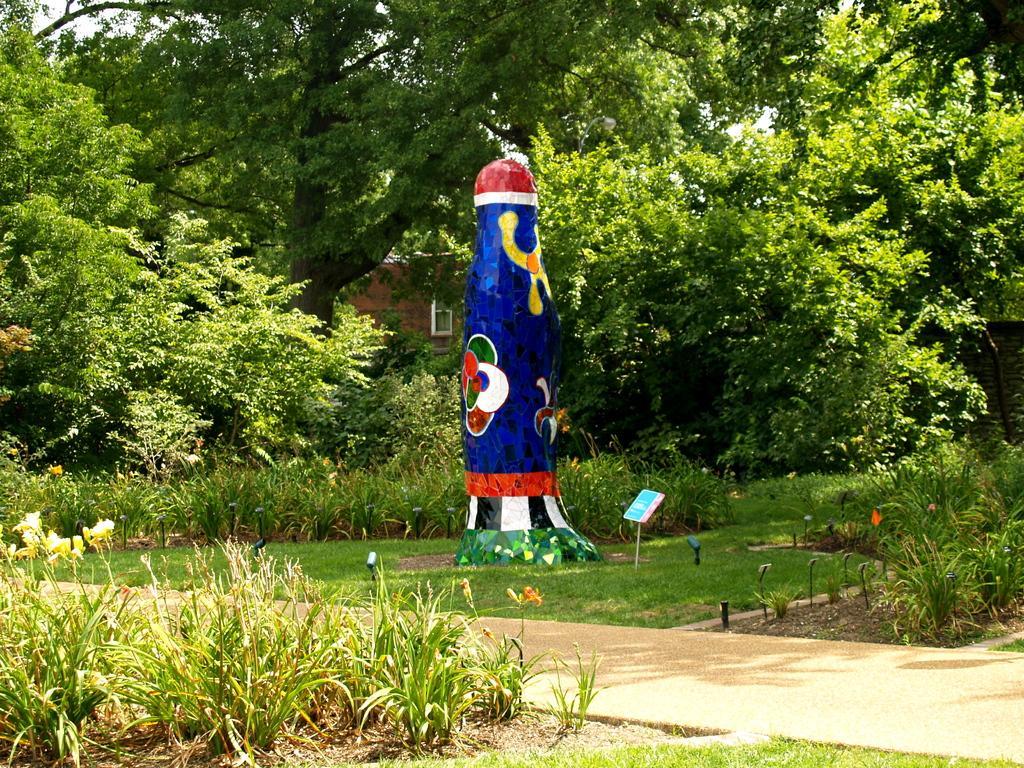What type of area is depicted in the image? There is a garden in the image. What is the surface of the garden made of? The garden has a grass surface. What types of vegetation can be found in the garden? There are plants and trees in the garden. Can you describe the bottle-like structure on the grass surface? There is a bottle-like structure on the grass surface, but its purpose or function is not clear from the image. What can be seen in the background of the image? There are trees visible in the background of the image. What type of force is being applied to the popcorn in the image? There is no popcorn present in the image, so no force is being applied to it. What type of coil is visible in the image? There is no coil visible in the image. 